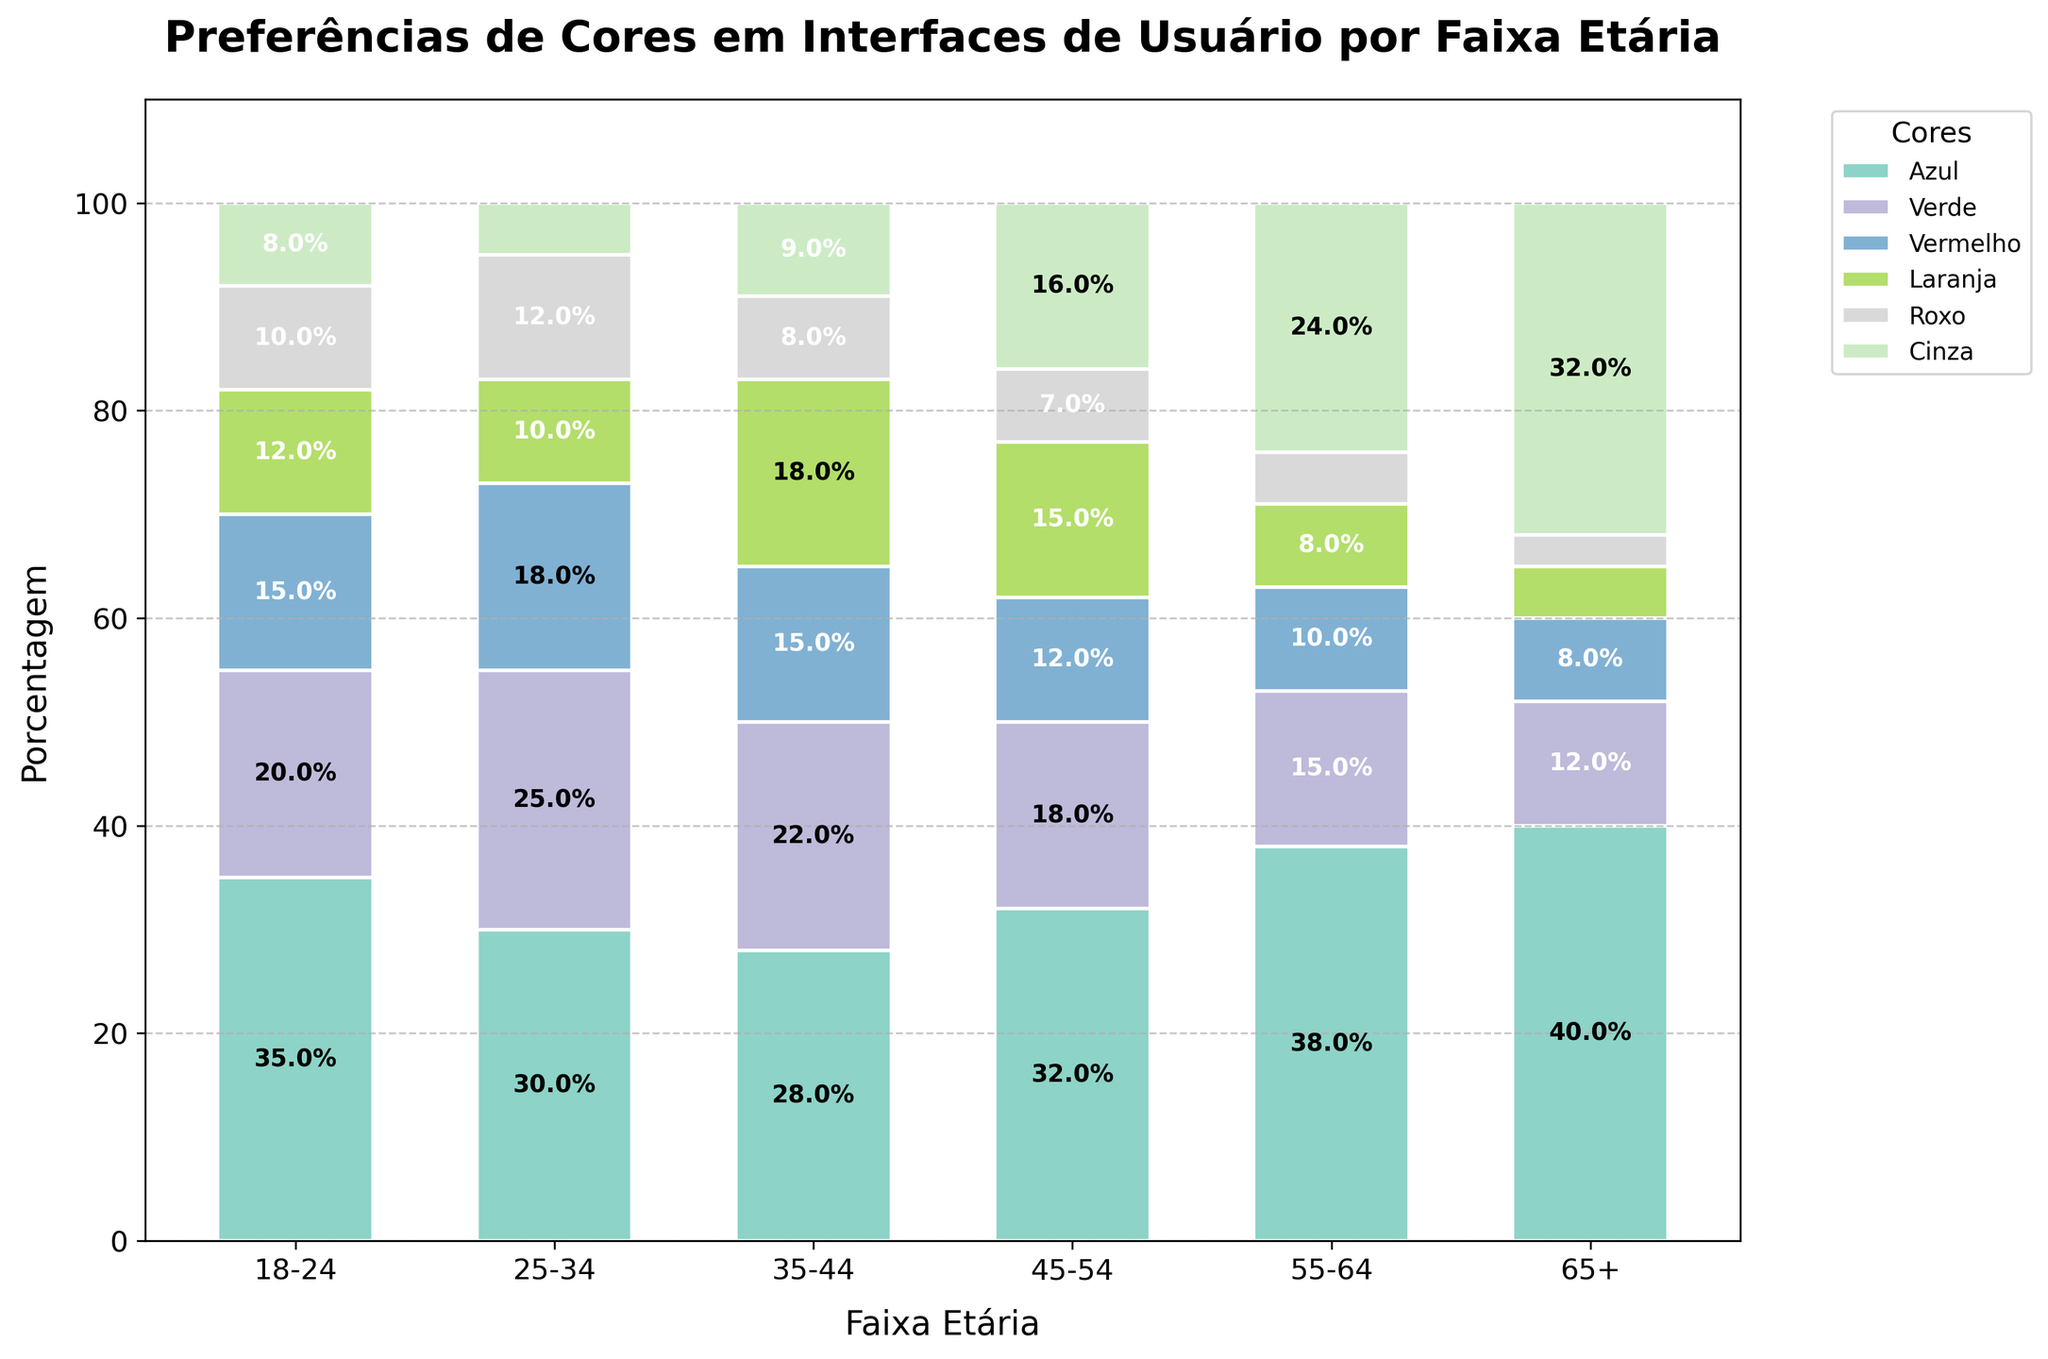What is the most preferred color for the age group 25-34? The tallest bar representing the age group 25-34 is the blue one. This indicates that the blue color has the highest percentage preference in this age group.
Answer: Blue Which age group has the highest preference for the color gray (cinza)? The tallest gray bar in the chart corresponds to the 65+ age group, indicating this group's highest preference for gray.
Answer: 65+ Is the percentage preference for the color red (vermelho) larger in the age group 18-24 or 45-54? By comparing the height of the red bars for the 18-24 and 45-54 age groups, the red bar is taller for the 18-24 age group.
Answer: 18-24 Which age group has the least preference for the color purple (roxo)? The smallest purple bar corresponds to the 65+ age group, indicating the lowest preference for purple.
Answer: 65+ Summarize the total preference percentage for the color green (verde) across all age groups. Sum all green values: 20 (18-24) + 25 (25-34) + 22 (35-44) + 18 (45-54) + 15 (55-64) + 12 (65+) = 112.
Answer: 112 By what percentage does the preference for the color orange (laranja) decrease from the age group 35-44 to the age group 55-64? The percentage for orange in 35-44 is 18 and in 55-64 is 8. The decrease is 18 - 8 = 10.
Answer: 10 Which color has the highest cumulative preference percentage across all age groups? Summing the preference percentages of each color across all age groups yields the following totals: Azul: 203, Verde: 112, Vermelho: 78, Laranja: 68, Roxo: 45, Cinza: 94. Blue has the highest cumulative preference.
Answer: Blue Compare the percentage preference for the color blue between the youngest (18-24) and the oldest (65+) age groups. The percentage preference for blue in the 18-24 age group is 35, and for the 65+ age group, it is 40.
Answer: 65+ What is the average percentage preference for the color red (vermelho) among all age groups? Sum all red values: 15 (18-24) + 18 (25-34) + 15 (35-44) + 12 (45-54) + 10 (55-64) + 8 (65+), which totals 78. Then divide by the number of age groups, 6. 78 / 6 = 13.
Answer: 13 